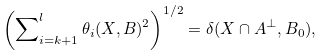<formula> <loc_0><loc_0><loc_500><loc_500>\left ( \sum \nolimits _ { i = k + 1 } ^ { l } \theta _ { i } ( X , B ) ^ { 2 } \right ) ^ { 1 / 2 } = \delta ( X \cap A ^ { \perp } , B _ { 0 } ) ,</formula> 